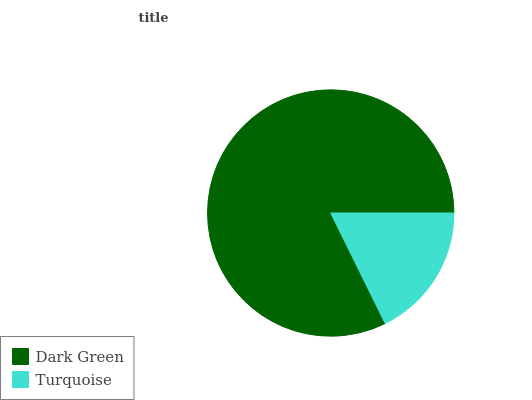Is Turquoise the minimum?
Answer yes or no. Yes. Is Dark Green the maximum?
Answer yes or no. Yes. Is Turquoise the maximum?
Answer yes or no. No. Is Dark Green greater than Turquoise?
Answer yes or no. Yes. Is Turquoise less than Dark Green?
Answer yes or no. Yes. Is Turquoise greater than Dark Green?
Answer yes or no. No. Is Dark Green less than Turquoise?
Answer yes or no. No. Is Dark Green the high median?
Answer yes or no. Yes. Is Turquoise the low median?
Answer yes or no. Yes. Is Turquoise the high median?
Answer yes or no. No. Is Dark Green the low median?
Answer yes or no. No. 